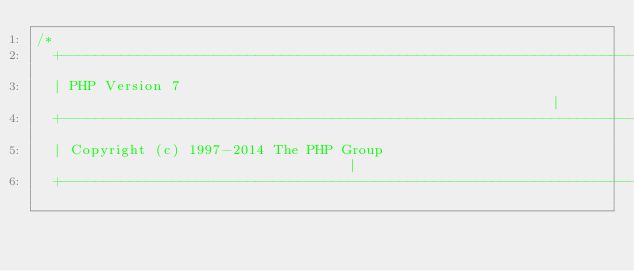<code> <loc_0><loc_0><loc_500><loc_500><_C_>/*
  +----------------------------------------------------------------------+
  | PHP Version 7                                                        |
  +----------------------------------------------------------------------+
  | Copyright (c) 1997-2014 The PHP Group                                |
  +----------------------------------------------------------------------+</code> 